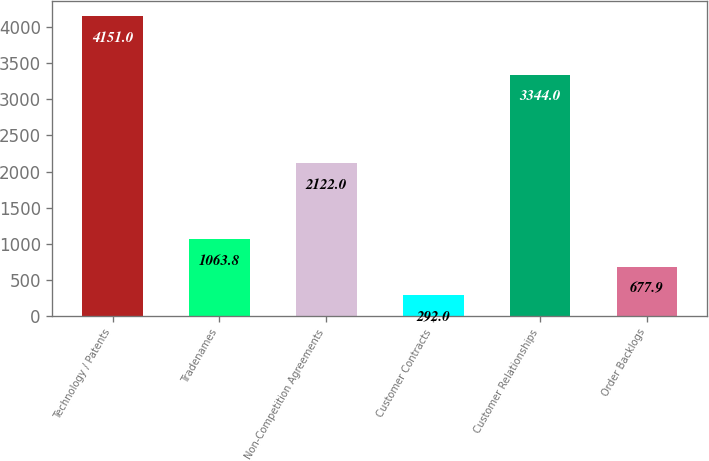<chart> <loc_0><loc_0><loc_500><loc_500><bar_chart><fcel>Technology / Patents<fcel>Tradenames<fcel>Non-Competition Agreements<fcel>Customer Contracts<fcel>Customer Relationships<fcel>Order Backlogs<nl><fcel>4151<fcel>1063.8<fcel>2122<fcel>292<fcel>3344<fcel>677.9<nl></chart> 